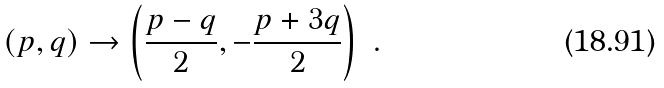Convert formula to latex. <formula><loc_0><loc_0><loc_500><loc_500>( p , q ) \to \left ( \frac { p - q } 2 , - \frac { p + 3 q } 2 \right ) \ .</formula> 